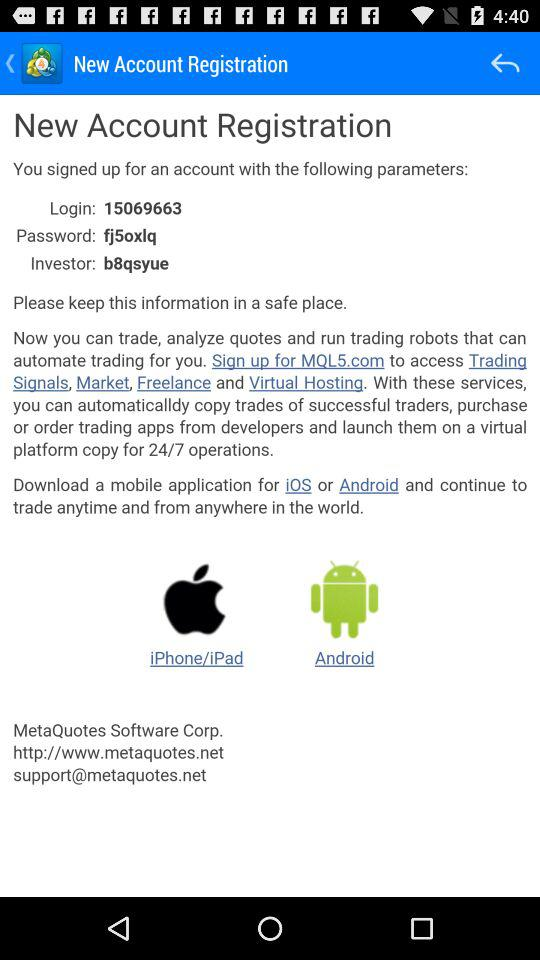What is the password for the registered account? The password for the registered account is "fj5oxlq". 